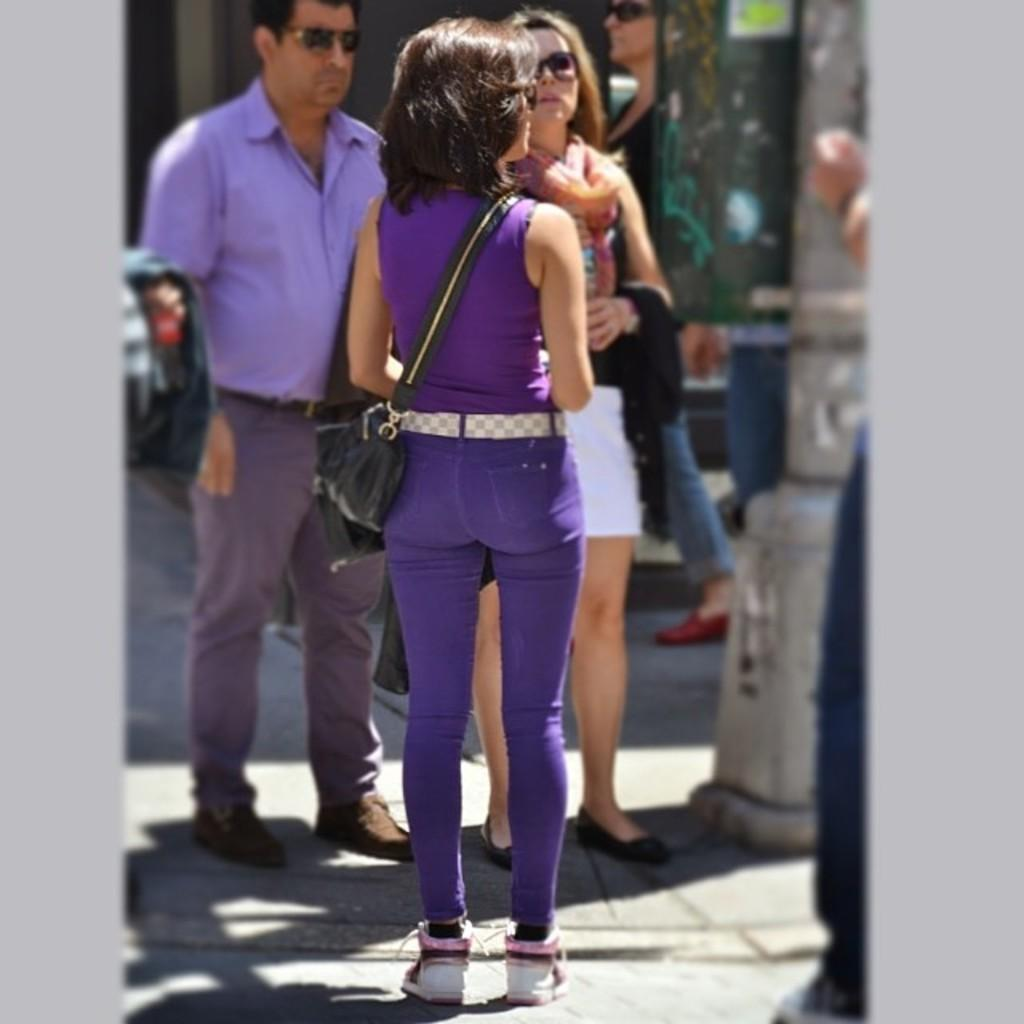What is the main subject of the image? There is a woman standing in the image. Can you describe the background of the image? There are people standing in the background of the image, along with some objects. How many dimes does the woman have in her pocket in the image? There is no information about the woman's pocket or the presence of dimes in the image. 